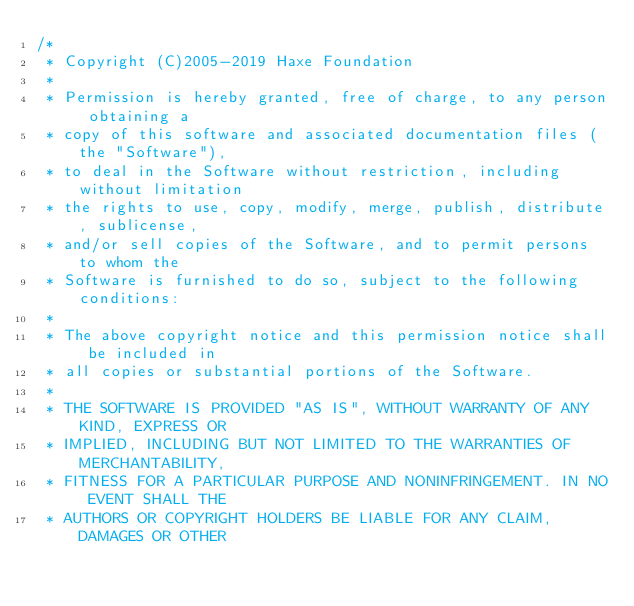Convert code to text. <code><loc_0><loc_0><loc_500><loc_500><_Haxe_>/*
 * Copyright (C)2005-2019 Haxe Foundation
 *
 * Permission is hereby granted, free of charge, to any person obtaining a
 * copy of this software and associated documentation files (the "Software"),
 * to deal in the Software without restriction, including without limitation
 * the rights to use, copy, modify, merge, publish, distribute, sublicense,
 * and/or sell copies of the Software, and to permit persons to whom the
 * Software is furnished to do so, subject to the following conditions:
 *
 * The above copyright notice and this permission notice shall be included in
 * all copies or substantial portions of the Software.
 *
 * THE SOFTWARE IS PROVIDED "AS IS", WITHOUT WARRANTY OF ANY KIND, EXPRESS OR
 * IMPLIED, INCLUDING BUT NOT LIMITED TO THE WARRANTIES OF MERCHANTABILITY,
 * FITNESS FOR A PARTICULAR PURPOSE AND NONINFRINGEMENT. IN NO EVENT SHALL THE
 * AUTHORS OR COPYRIGHT HOLDERS BE LIABLE FOR ANY CLAIM, DAMAGES OR OTHER</code> 